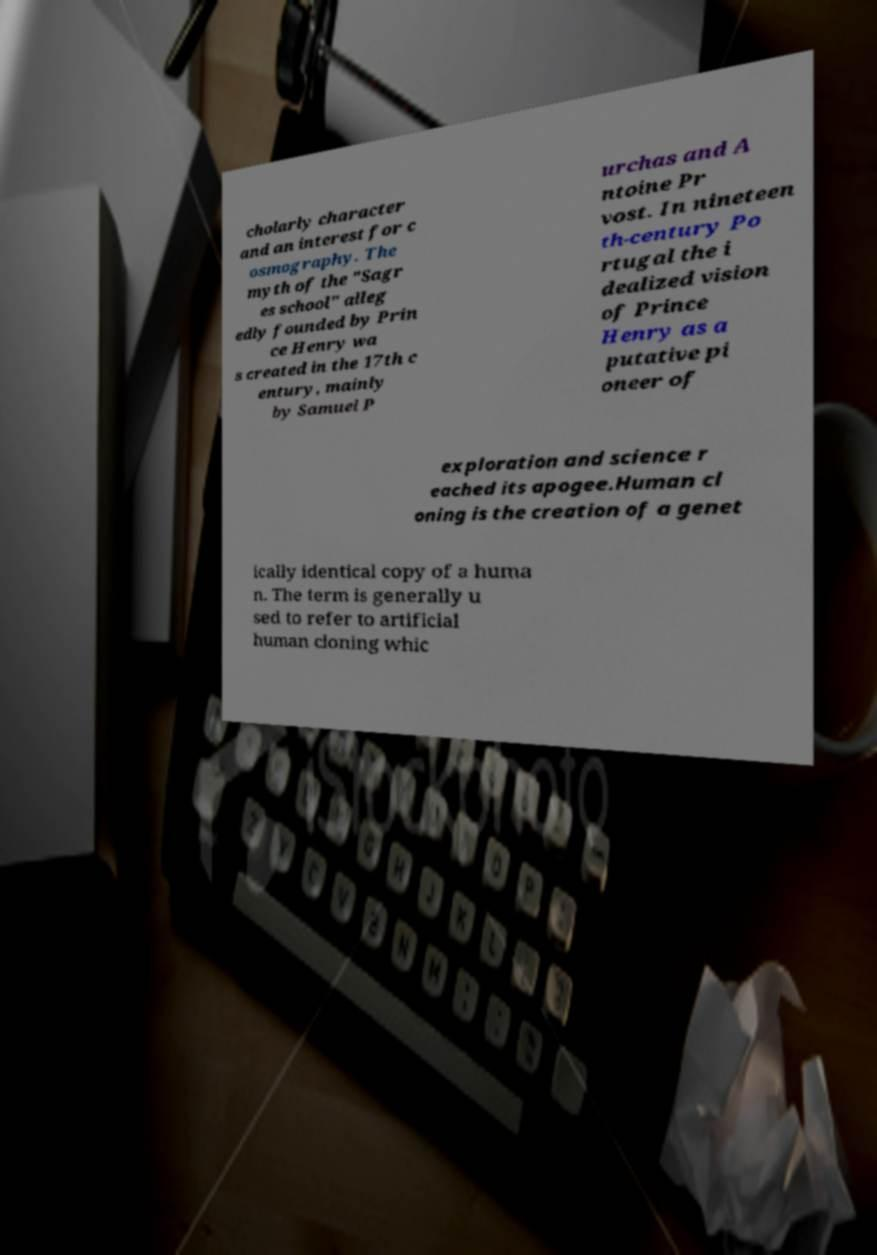For documentation purposes, I need the text within this image transcribed. Could you provide that? cholarly character and an interest for c osmography. The myth of the "Sagr es school" alleg edly founded by Prin ce Henry wa s created in the 17th c entury, mainly by Samuel P urchas and A ntoine Pr vost. In nineteen th-century Po rtugal the i dealized vision of Prince Henry as a putative pi oneer of exploration and science r eached its apogee.Human cl oning is the creation of a genet ically identical copy of a huma n. The term is generally u sed to refer to artificial human cloning whic 